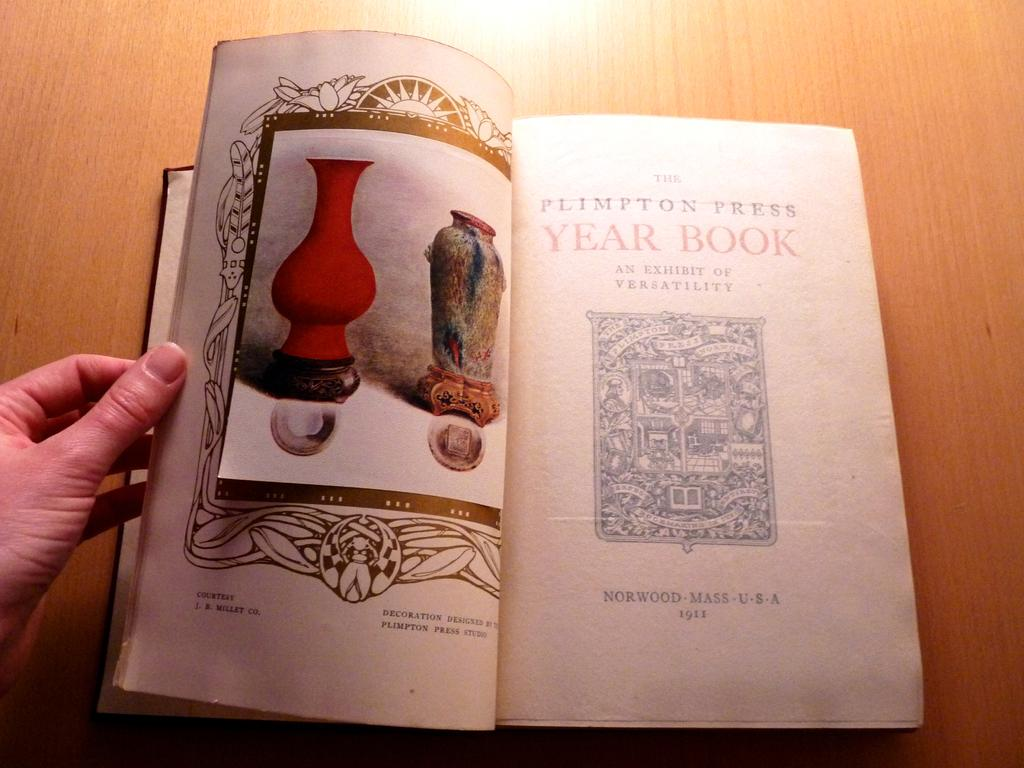<image>
Give a short and clear explanation of the subsequent image. A hand holds the Plimpton Press Year Book open to its title page. 